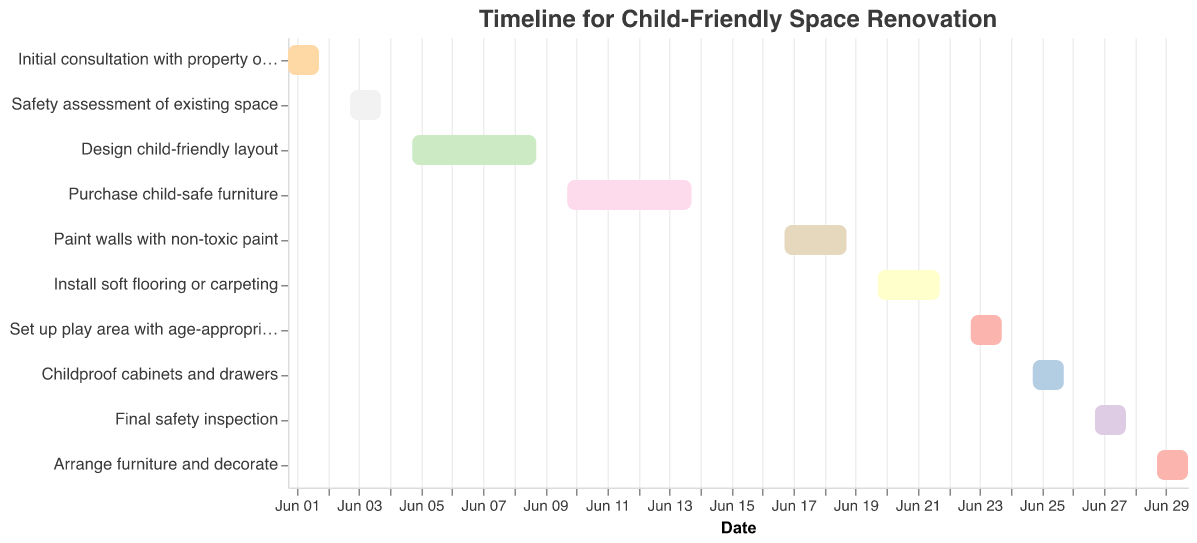How many tasks are there in total for the renovation? Count the number of bars on the Gantt chart. There are 10 tasks in total.
Answer: 10 What is the title of the Gantt chart? Look at the title at the top of the chart. The title is "Timeline for Child-Friendly Space Renovation."
Answer: Timeline for Child-Friendly Space Renovation Which task has the longest duration? Compare the durations of all the tasks and identify the longest one. Both "Design child-friendly layout" and "Purchase child-safe furniture" have the longest duration of 5 days.
Answer: Design child-friendly layout and Purchase child-safe furniture What is the first task scheduled to start? Check the task listed at the earliest start date, which is June 1, 2023. The task is "Initial consultation with property owner."
Answer: Initial consultation with property owner Which tasks have a duration of 2 days? Identify tasks that span exactly 2 days. The tasks are "Initial consultation with property owner," "Safety assessment of existing space," "Set up play area with age-appropriate toys," "Childproof cabinets and drawers," "Final safety inspection," and "Arrange furniture and decorate."
Answer: Initial consultation with property owner, Safety assessment of existing space, Set up play area with age-appropriate toys, Childproof cabinets and drawers, Final safety inspection, Arrange furniture and decorate Which task ends on June 30, 2023? Look at the end dates of all tasks and find the one that ends on June 30, 2023. The task is "Arrange furniture and decorate."
Answer: Arrange furniture and decorate How many tasks are scheduled to start in June 2023? Since all tasks start in June 2023, the total number of tasks is the number of entries, which is 10.
Answer: 10 What is the total duration of tasks from "Design child-friendly layout" to "Install soft flooring or carpeting"? Sum the durations from "Design child-friendly layout," "Purchase child-safe furniture," "Paint walls with non-toxic paint," and "Install soft flooring or carpeting" (5 + 5 + 3 + 3).
Answer: 16 days Which comes first: "Final safety inspection" or "Set up play area with age-appropriate toys"? Compare the start dates of these two tasks. The "Set up play area with age-appropriate toys" starts on June 23, 2023, and the "Final safety inspection" starts on June 27, 2023.
Answer: Set up play area with age-appropriate toys 